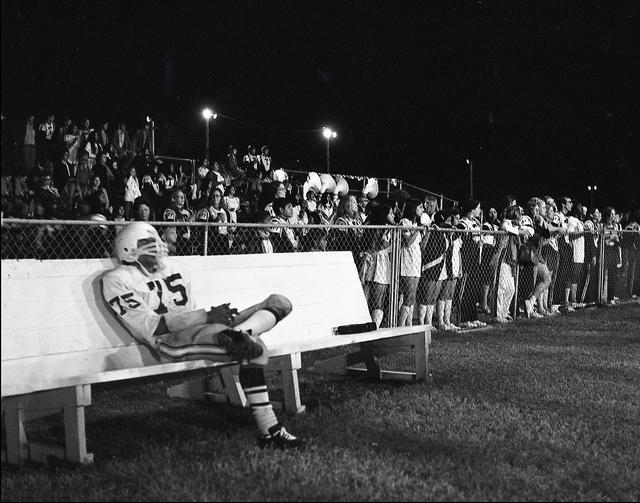How many people are sitting on the bench?
Give a very brief answer. 1. How many people are there?
Give a very brief answer. 5. How many spoons are there?
Give a very brief answer. 0. 